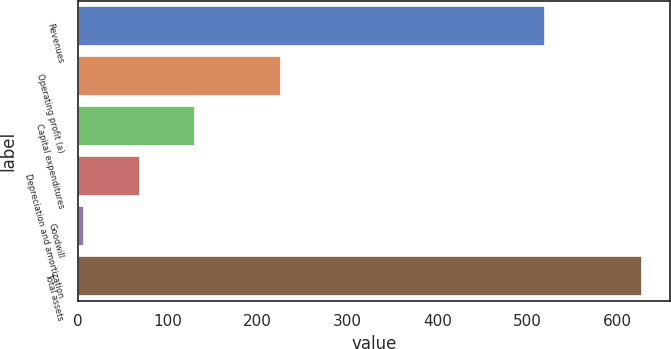<chart> <loc_0><loc_0><loc_500><loc_500><bar_chart><fcel>Revenues<fcel>Operating profit (a)<fcel>Capital expenditures<fcel>Depreciation and amortization<fcel>Goodwill<fcel>Total assets<nl><fcel>520<fcel>225.6<fcel>130.66<fcel>68.48<fcel>6.3<fcel>628.1<nl></chart> 